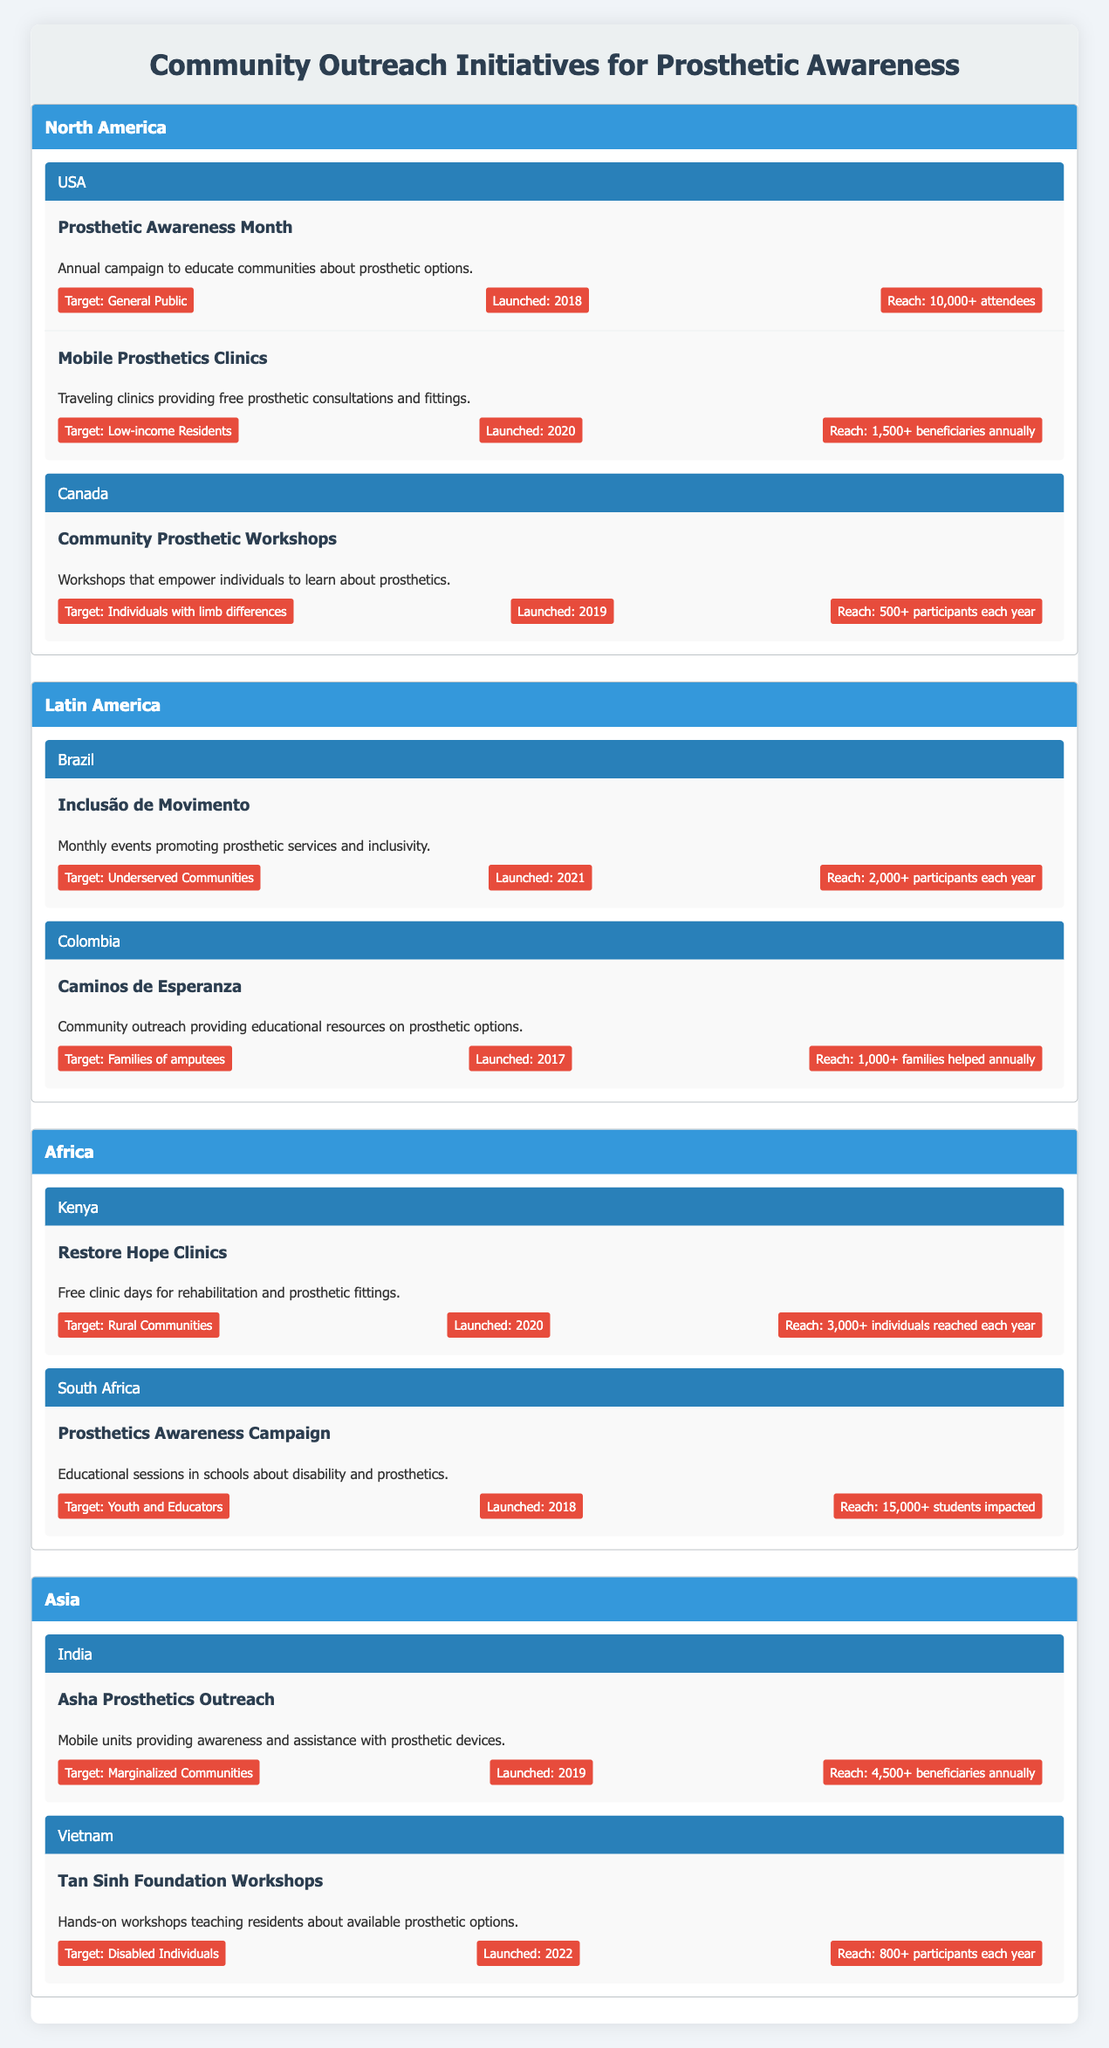What are the prosthetic outreach initiatives in the USA? The table shows two initiatives: "Prosthetic Awareness Month," which is an annual campaign to educate communities about prosthetic options, and "Mobile Prosthetics Clinics," which are traveling clinics providing free consultations and fittings
Answer: Prosthetic Awareness Month and Mobile Prosthetics Clinics How many participants are reached by the Prosthetics Awareness Campaign in South Africa? The "Prosthetics Awareness Campaign" initiative in South Africa states that it impacts over 15,000 students
Answer: 15,000+ students impacted Which initiative in Latin America targets families of amputees? The initiative "Caminos de Esperanza" in Colombia is specifically intended for families of amputees, as indicated in the table
Answer: Caminos de Esperanza Which region has the highest reach reported for outreach initiatives? Comparing the reach across reported initiatives, South Africa's "Prosthetics Awareness Campaign" has the highest with more than 15,000 students, followed by the USA's "Prosthetic Awareness Month" with 10,000+ attendees and Kenya's "Restore Hope Clinics" reaching over 3,000 individuals. Therefore, Africa has the highest reach at 15,000+
Answer: Africa Are there any initiatives launched before 2018 in North America? There are two initiatives: "Prosthetic Awareness Month" launched in 2018, and "Mobile Prosthetics Clinics" launched in 2020 in the USA, while Canada has one initiative launched in 2019. Therefore, all initiatives in North America were launched in 2018 or later
Answer: No What is the total number of beneficiaries reached by the Mobile Prosthetics Clinics and Asha Prosthetics Outreach? The Mobile Prosthetics Clinics reach 1,500+ beneficiaries annually, and Asha Prosthetics Outreach reaches 4,500+ beneficiaries annually. Summing them gives a reach of over 6,000 beneficiaries
Answer: Over 6,000 beneficiaries Which initiative can be described as a hands-on workshop for teaching about prosthetics? "Tan Sinh Foundation Workshops" in Vietnam are categorized as hands-on workshops for teaching residents about available prosthetic options, as described in the table
Answer: Tan Sinh Foundation Workshops Which country in Asia launched its initiative most recently? In the data, Vietnam launched its initiative "Tan Sinh Foundation Workshops" in 2022, which is the most recent launch date among Asian countries listed
Answer: Vietnam 